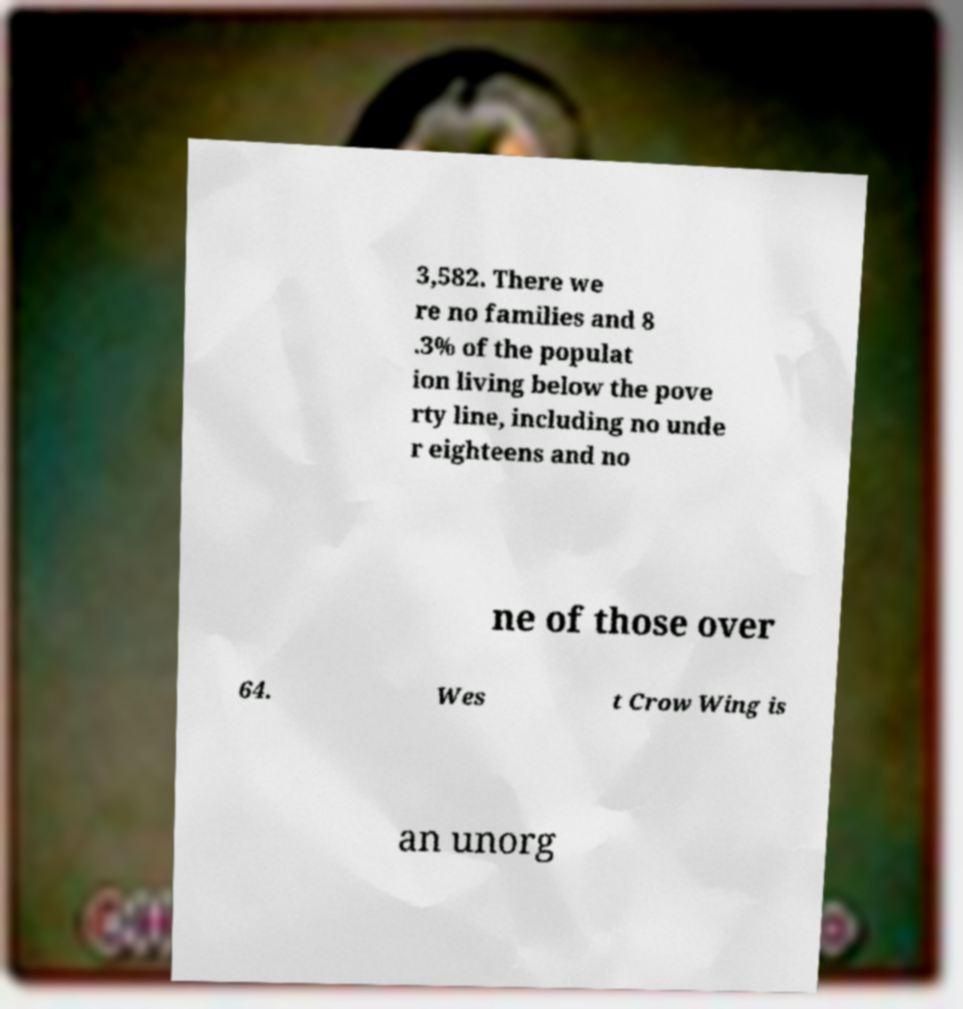Could you extract and type out the text from this image? 3,582. There we re no families and 8 .3% of the populat ion living below the pove rty line, including no unde r eighteens and no ne of those over 64. Wes t Crow Wing is an unorg 